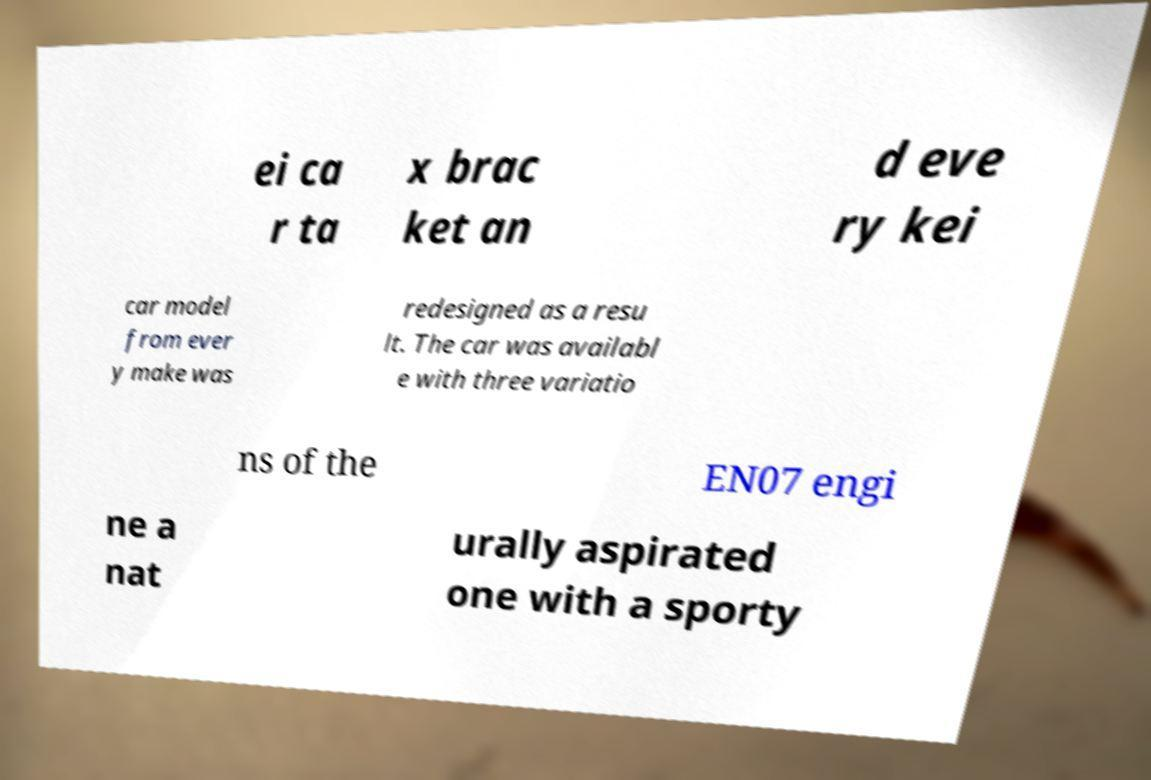Could you assist in decoding the text presented in this image and type it out clearly? ei ca r ta x brac ket an d eve ry kei car model from ever y make was redesigned as a resu lt. The car was availabl e with three variatio ns of the EN07 engi ne a nat urally aspirated one with a sporty 